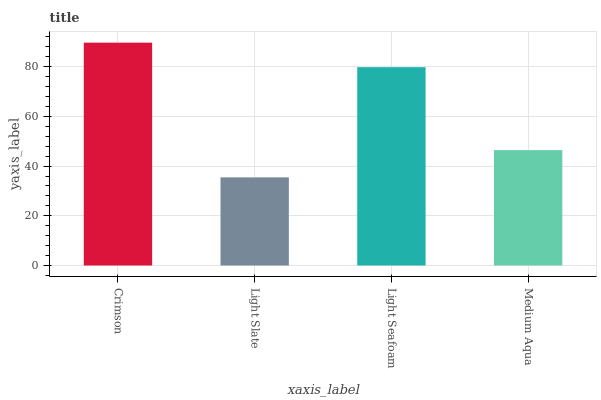Is Light Slate the minimum?
Answer yes or no. Yes. Is Crimson the maximum?
Answer yes or no. Yes. Is Light Seafoam the minimum?
Answer yes or no. No. Is Light Seafoam the maximum?
Answer yes or no. No. Is Light Seafoam greater than Light Slate?
Answer yes or no. Yes. Is Light Slate less than Light Seafoam?
Answer yes or no. Yes. Is Light Slate greater than Light Seafoam?
Answer yes or no. No. Is Light Seafoam less than Light Slate?
Answer yes or no. No. Is Light Seafoam the high median?
Answer yes or no. Yes. Is Medium Aqua the low median?
Answer yes or no. Yes. Is Medium Aqua the high median?
Answer yes or no. No. Is Light Slate the low median?
Answer yes or no. No. 